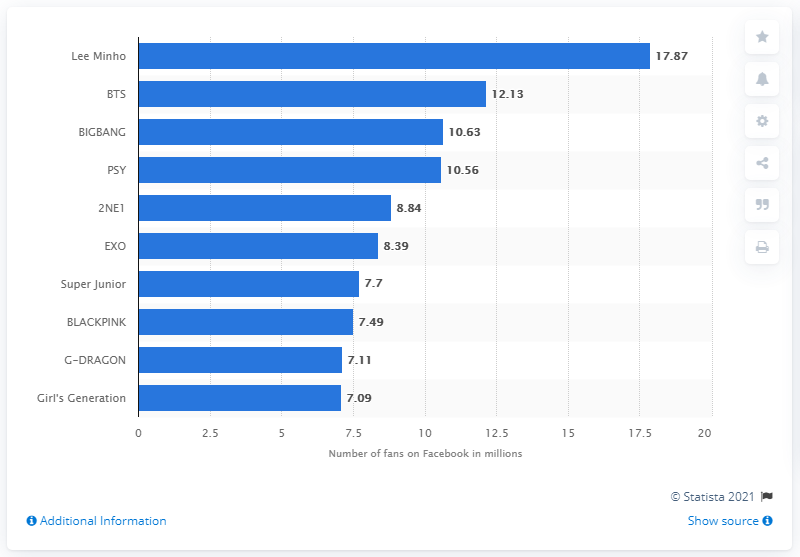Mention a couple of crucial points in this snapshot. According to the latest data, Lee Min-ho has 17.87 million fans on Facebook. 